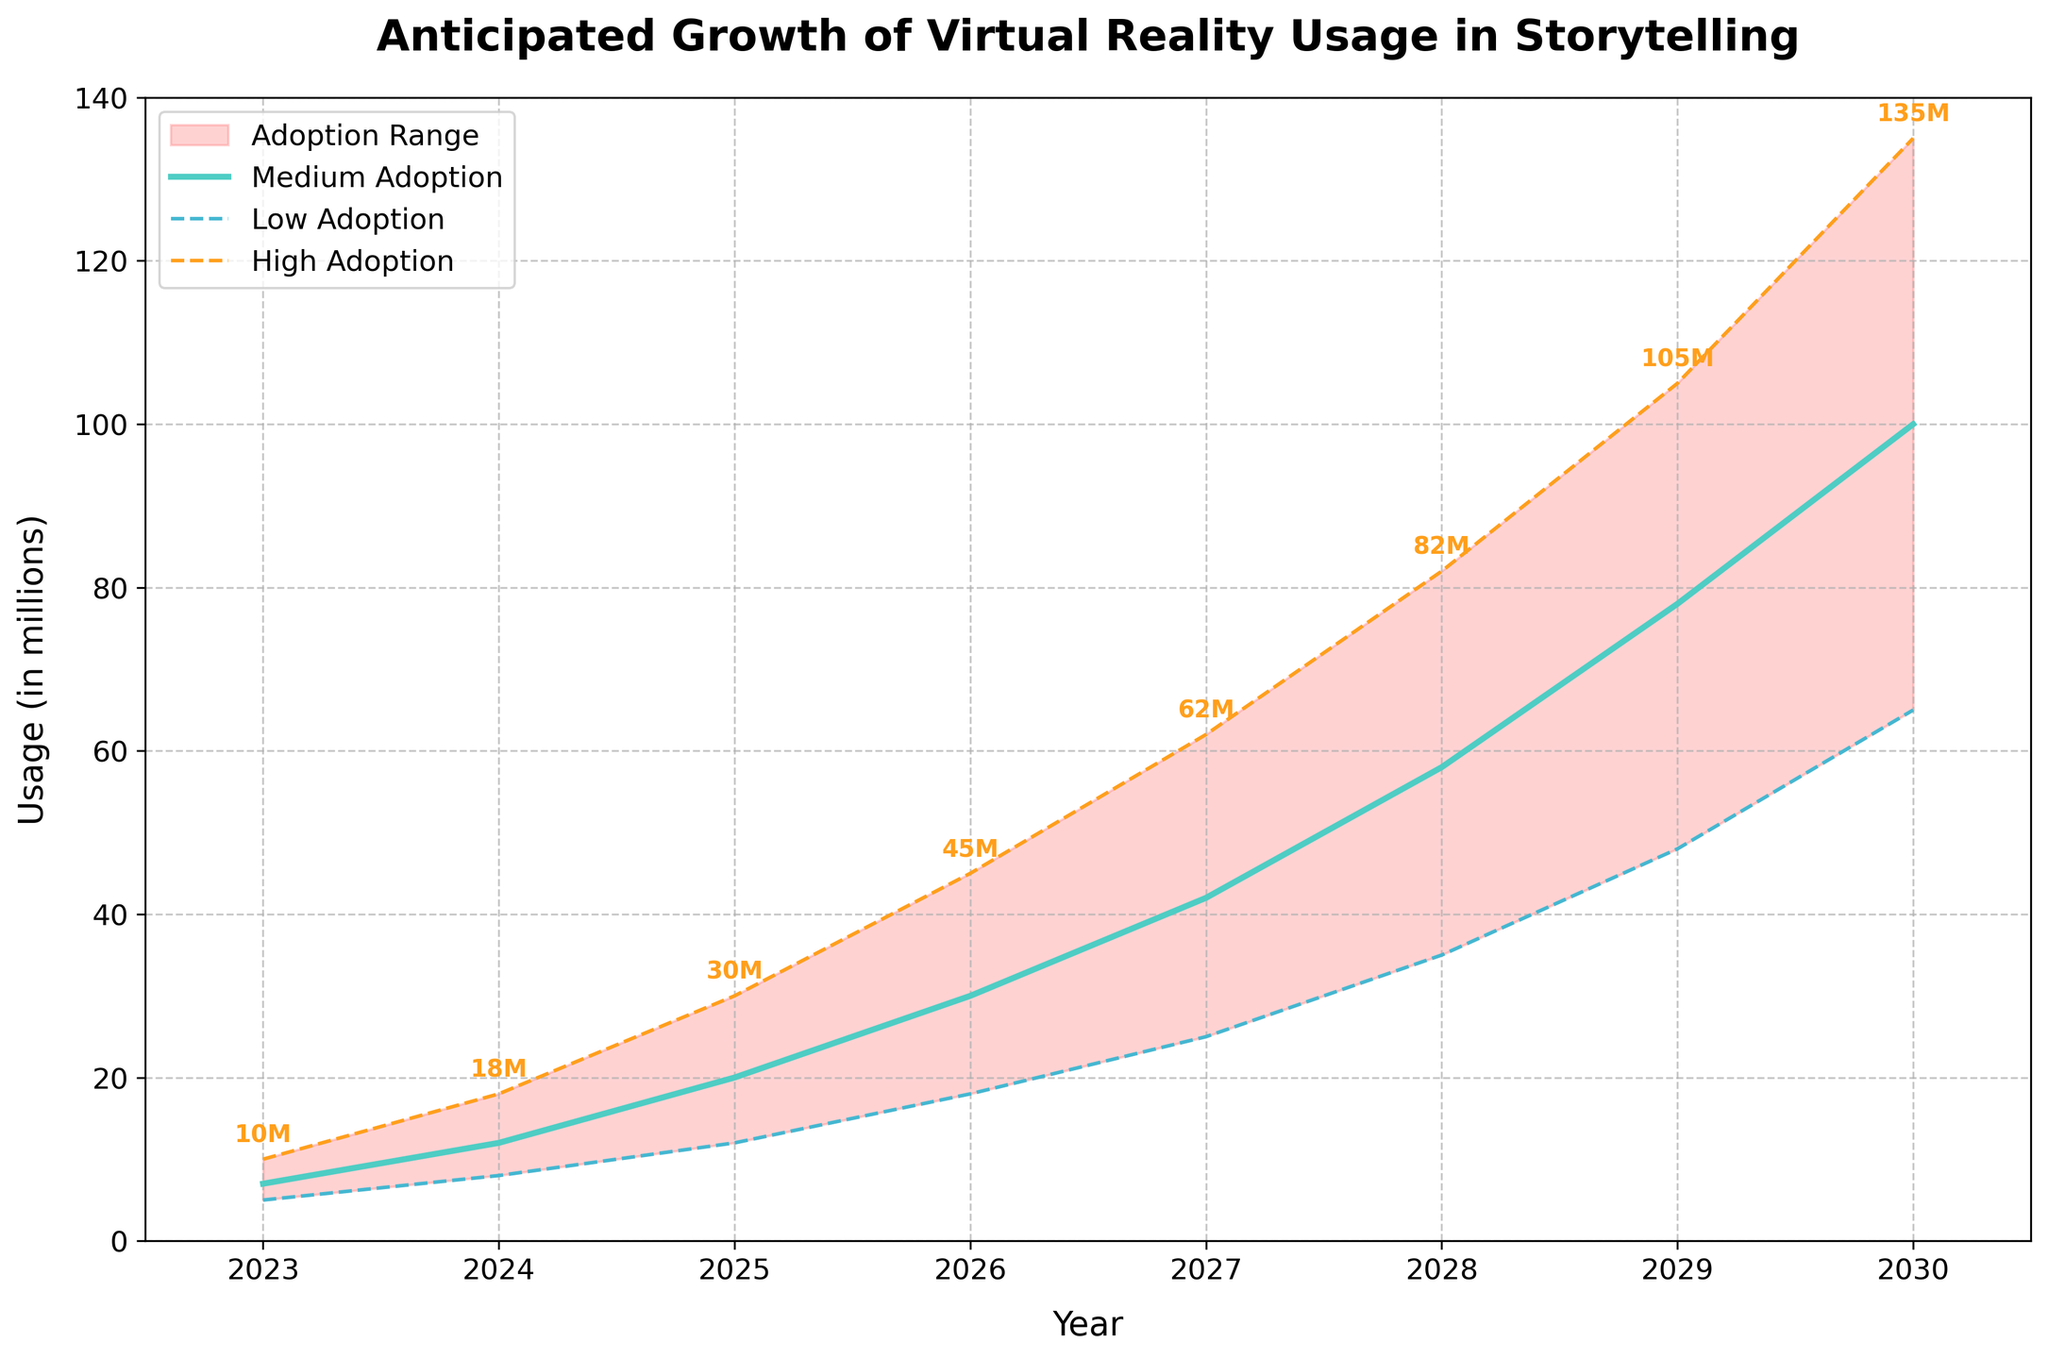what is the title of the figure? The title of the figure is located at the top and reads "Anticipated Growth of Virtual Reality Usage in Storytelling."
Answer: Anticipated Growth of Virtual Reality Usage in Storytelling What color represents the medium adoption rate in the chart? The medium adoption rate line is shown in a teal color as it is the most prominent line in the middle of the plotted area.
Answer: teal Between which years does the data in the figure range? By observing the x-axis, it is clear that the data ranges from the year 2023 to 2030.
Answer: 2023 to 2030 What is the highest anticipated usage in millions for the year 2030? By looking at the high adoption rate line, the highest anticipated usage in millions for 2030 is marked at 135 million.
Answer: 135 million In which year is the gap between high and low adoption rates the widest? By comparing the distances between the high and low adoption lines for each year, 2030 has the widest gap.
Answer: 2030 What is the anticipated usage for the medium adoption rate in 2025? Looking at the medium adoption line, the point corresponding to the year 2025 marks an anticipated usage of 20 million.
Answer: 20 million How much does the predicted high adoption rate increase between 2023 and 2024? The high adoption rate in 2023 is 10 million and in 2024 it is 18 million, so the increase is 18 - 10 = 8 million.
Answer: 8 million Which year shows the smallest anticipated usage for the low adoption rate? The low adoption rate line shows the smallest usage in the year 2023 with a value of 5 million.
Answer: 2023 How many millions are added to the medium adoption rate from 2026 to 2028? The medium adoption rate in 2026 is 30 million and in 2028 it is 58 million; the difference is 58 - 30 = 28 million.
Answer: 28 million By looking at the fan chart's gradient, describe the overall trend for virtual reality usage across all adoption rates. The gradient of the fan chart consistently rises from 2023 to 2030 for all adoption rates, indicating a steady increase in virtual reality usage in storytelling over these years.
Answer: steady increase 